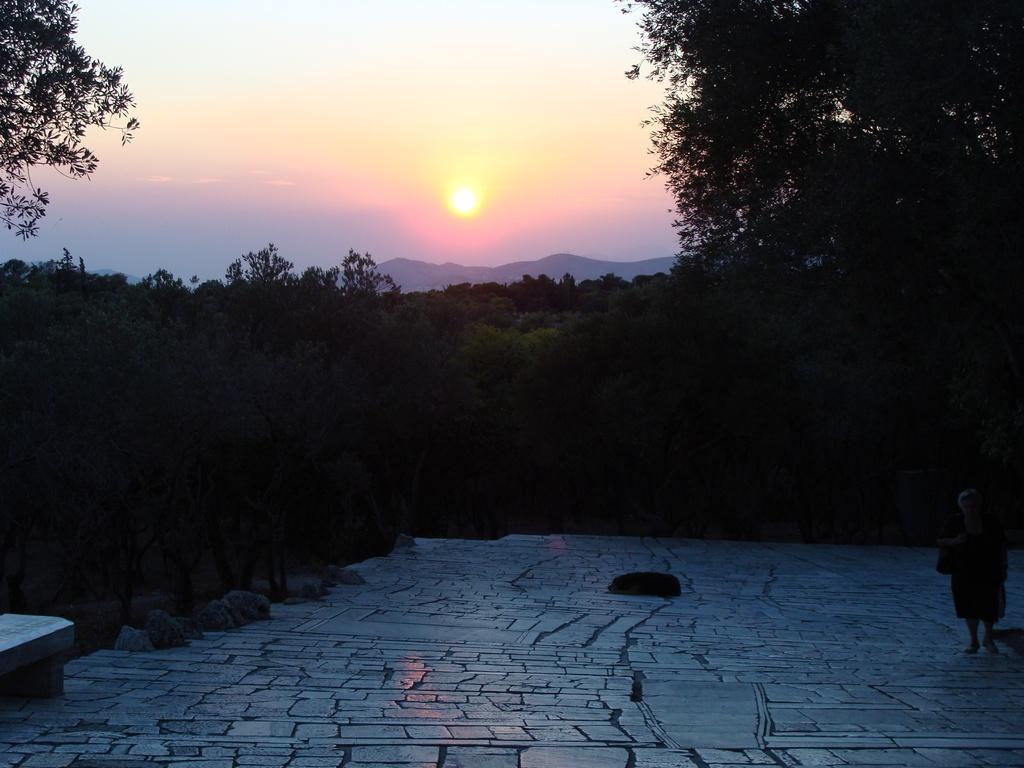In one or two sentences, can you explain what this image depicts? In this image, these are the trees with branches and leaves. At the bottom of the image, I can see a dog sleeping and a person standing. On the left side of the image, It looks like a bench and the rocks. In the background, I can see the mountains, which are behind the trees. This is the sun in the sky. 